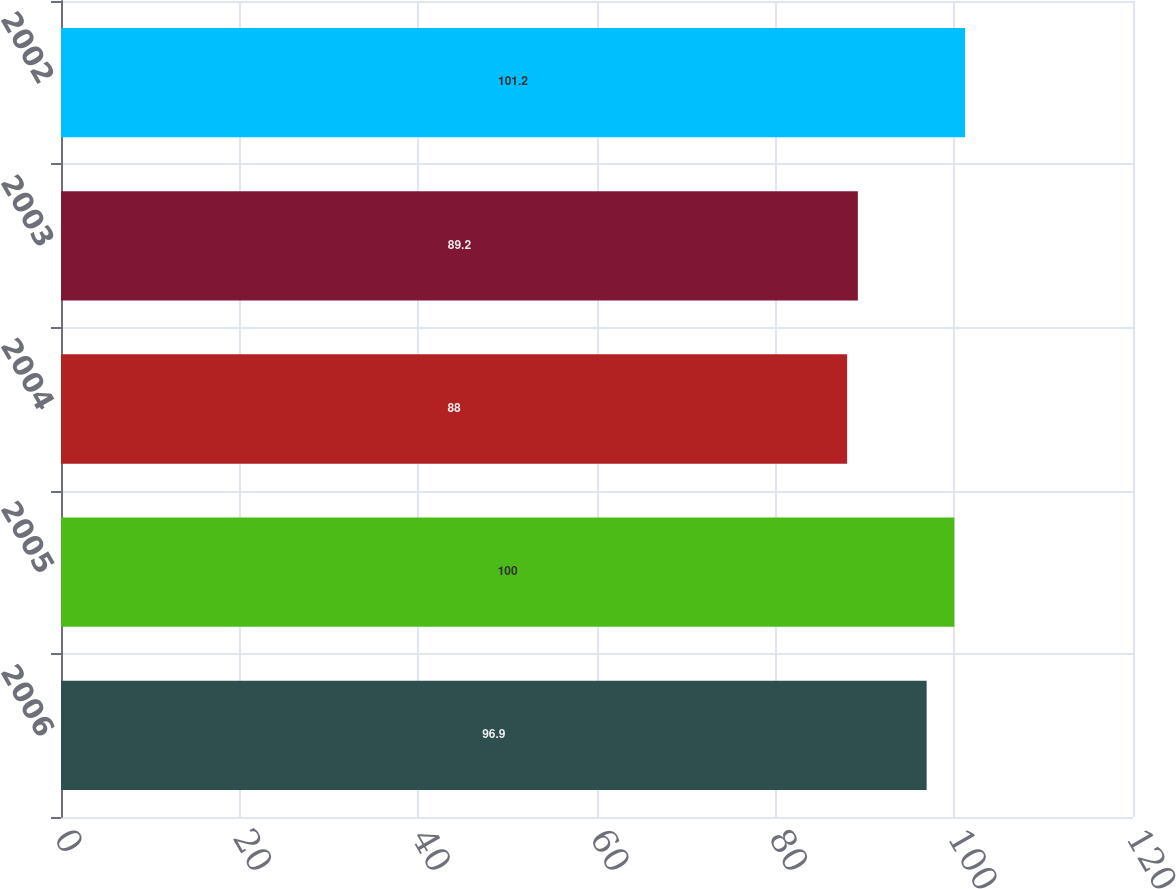Convert chart to OTSL. <chart><loc_0><loc_0><loc_500><loc_500><bar_chart><fcel>2006<fcel>2005<fcel>2004<fcel>2003<fcel>2002<nl><fcel>96.9<fcel>100<fcel>88<fcel>89.2<fcel>101.2<nl></chart> 